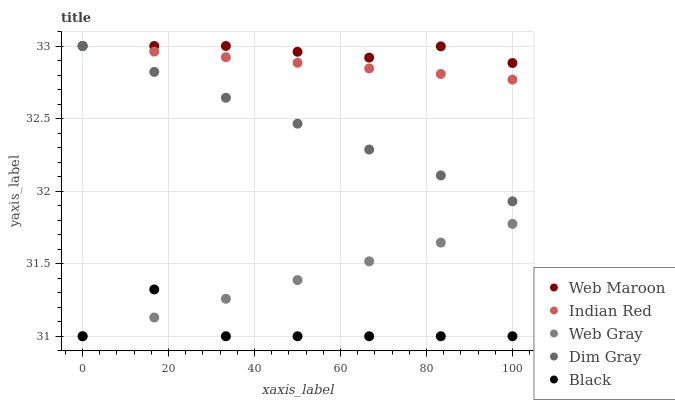Does Black have the minimum area under the curve?
Answer yes or no. Yes. Does Web Maroon have the maximum area under the curve?
Answer yes or no. Yes. Does Dim Gray have the minimum area under the curve?
Answer yes or no. No. Does Dim Gray have the maximum area under the curve?
Answer yes or no. No. Is Web Gray the smoothest?
Answer yes or no. Yes. Is Black the roughest?
Answer yes or no. Yes. Is Dim Gray the smoothest?
Answer yes or no. No. Is Dim Gray the roughest?
Answer yes or no. No. Does Black have the lowest value?
Answer yes or no. Yes. Does Dim Gray have the lowest value?
Answer yes or no. No. Does Indian Red have the highest value?
Answer yes or no. Yes. Does Web Gray have the highest value?
Answer yes or no. No. Is Web Gray less than Indian Red?
Answer yes or no. Yes. Is Web Maroon greater than Web Gray?
Answer yes or no. Yes. Does Dim Gray intersect Indian Red?
Answer yes or no. Yes. Is Dim Gray less than Indian Red?
Answer yes or no. No. Is Dim Gray greater than Indian Red?
Answer yes or no. No. Does Web Gray intersect Indian Red?
Answer yes or no. No. 